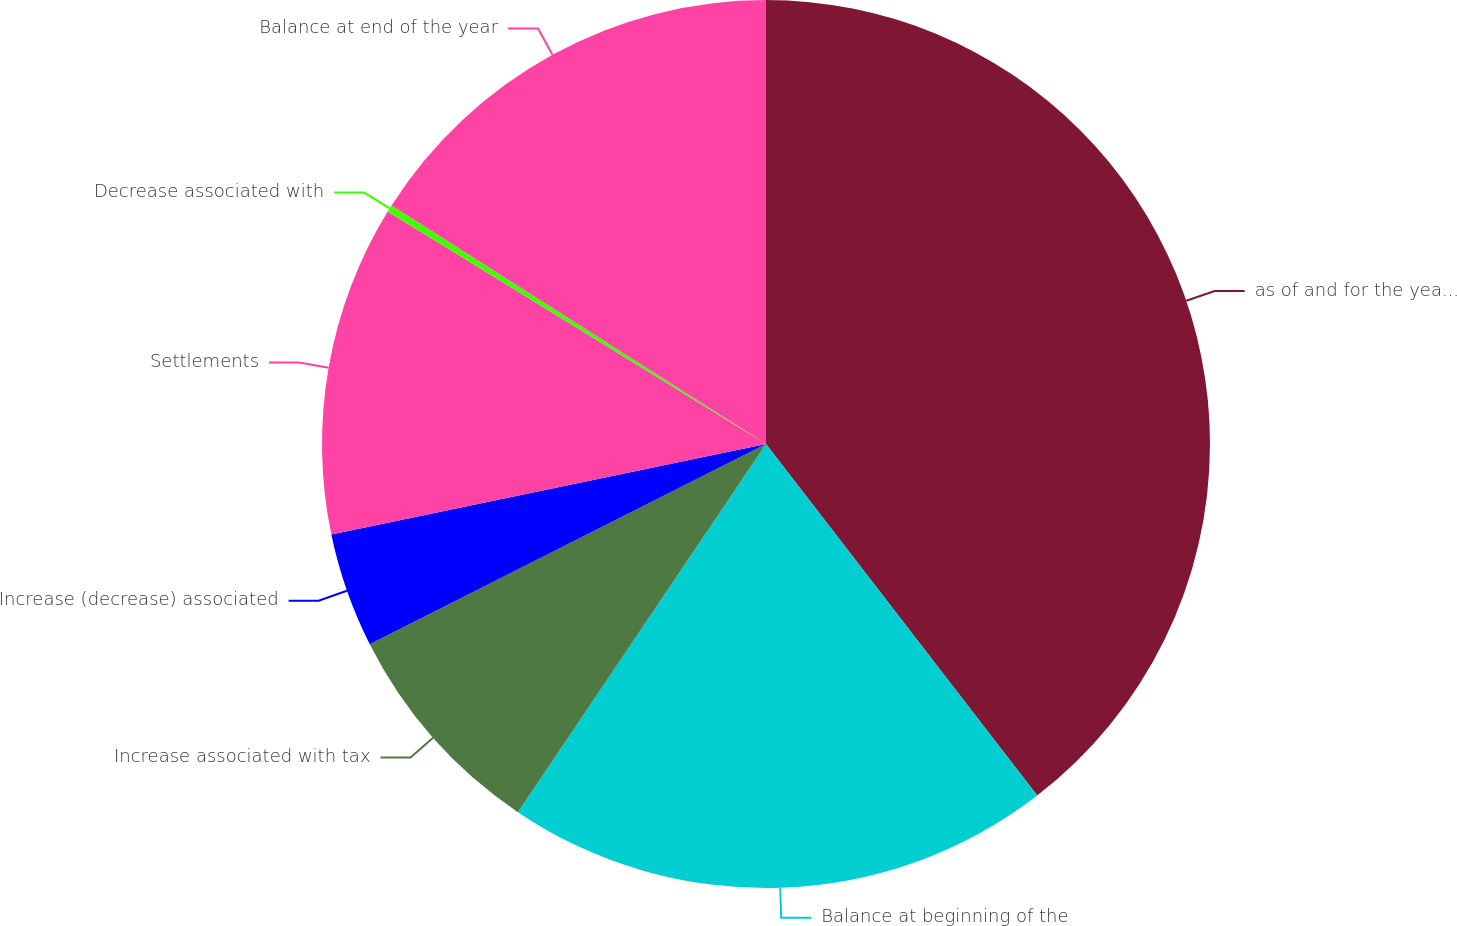Convert chart. <chart><loc_0><loc_0><loc_500><loc_500><pie_chart><fcel>as of and for the years ended<fcel>Balance at beginning of the<fcel>Increase associated with tax<fcel>Increase (decrease) associated<fcel>Settlements<fcel>Decrease associated with<fcel>Balance at end of the year<nl><fcel>39.54%<fcel>19.9%<fcel>8.11%<fcel>4.18%<fcel>12.04%<fcel>0.26%<fcel>15.97%<nl></chart> 